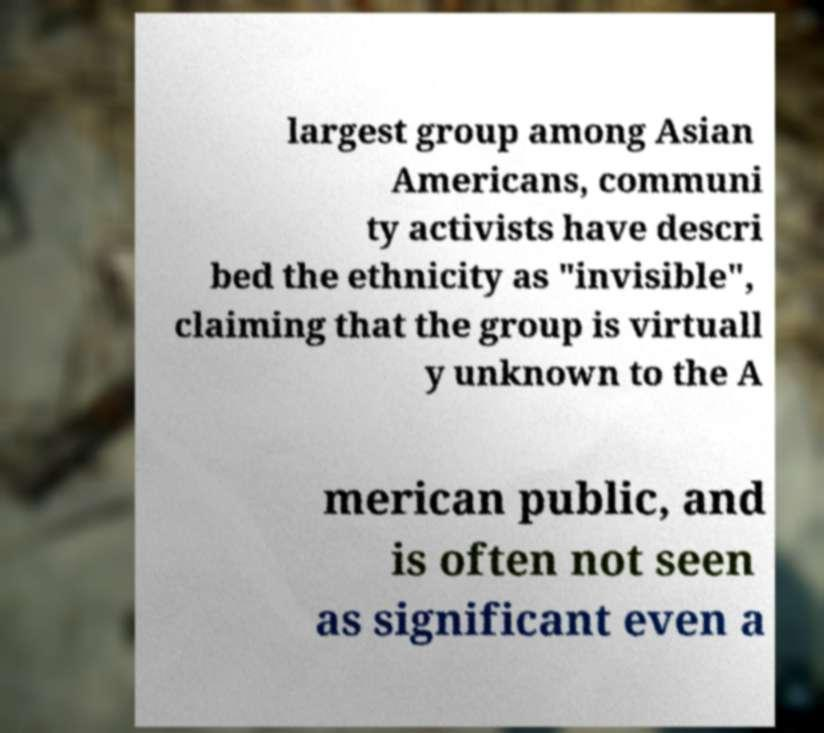What messages or text are displayed in this image? I need them in a readable, typed format. largest group among Asian Americans, communi ty activists have descri bed the ethnicity as "invisible", claiming that the group is virtuall y unknown to the A merican public, and is often not seen as significant even a 